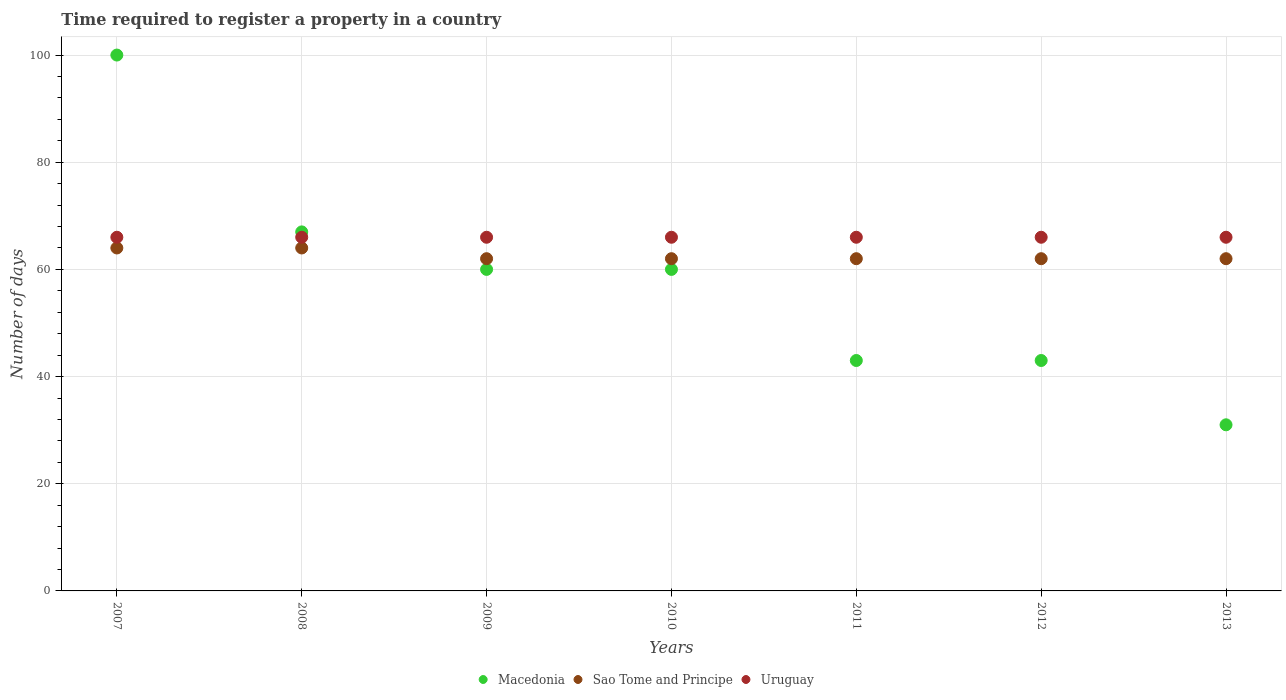How many different coloured dotlines are there?
Offer a terse response. 3. What is the number of days required to register a property in Sao Tome and Principe in 2009?
Make the answer very short. 62. Across all years, what is the maximum number of days required to register a property in Sao Tome and Principe?
Your answer should be very brief. 64. Across all years, what is the minimum number of days required to register a property in Sao Tome and Principe?
Offer a terse response. 62. What is the total number of days required to register a property in Macedonia in the graph?
Provide a succinct answer. 404. What is the difference between the number of days required to register a property in Macedonia in 2011 and the number of days required to register a property in Uruguay in 2007?
Give a very brief answer. -23. What is the average number of days required to register a property in Sao Tome and Principe per year?
Your response must be concise. 62.57. In the year 2007, what is the difference between the number of days required to register a property in Sao Tome and Principe and number of days required to register a property in Uruguay?
Your answer should be compact. -2. What is the ratio of the number of days required to register a property in Uruguay in 2007 to that in 2013?
Ensure brevity in your answer.  1. What is the difference between the highest and the lowest number of days required to register a property in Sao Tome and Principe?
Provide a short and direct response. 2. In how many years, is the number of days required to register a property in Uruguay greater than the average number of days required to register a property in Uruguay taken over all years?
Provide a succinct answer. 0. Does the number of days required to register a property in Uruguay monotonically increase over the years?
Keep it short and to the point. No. What is the difference between two consecutive major ticks on the Y-axis?
Ensure brevity in your answer.  20. Does the graph contain any zero values?
Give a very brief answer. No. Does the graph contain grids?
Give a very brief answer. Yes. How many legend labels are there?
Ensure brevity in your answer.  3. What is the title of the graph?
Provide a short and direct response. Time required to register a property in a country. What is the label or title of the X-axis?
Offer a very short reply. Years. What is the label or title of the Y-axis?
Keep it short and to the point. Number of days. What is the Number of days in Sao Tome and Principe in 2007?
Make the answer very short. 64. What is the Number of days in Uruguay in 2007?
Offer a very short reply. 66. What is the Number of days of Macedonia in 2008?
Offer a very short reply. 67. What is the Number of days in Sao Tome and Principe in 2008?
Offer a very short reply. 64. What is the Number of days in Uruguay in 2008?
Provide a succinct answer. 66. What is the Number of days of Macedonia in 2009?
Give a very brief answer. 60. What is the Number of days in Uruguay in 2009?
Ensure brevity in your answer.  66. What is the Number of days of Macedonia in 2010?
Offer a terse response. 60. What is the Number of days in Sao Tome and Principe in 2010?
Keep it short and to the point. 62. What is the Number of days in Sao Tome and Principe in 2011?
Your answer should be compact. 62. What is the Number of days in Sao Tome and Principe in 2012?
Give a very brief answer. 62. What is the Number of days of Uruguay in 2012?
Make the answer very short. 66. What is the Number of days in Macedonia in 2013?
Make the answer very short. 31. What is the Number of days in Sao Tome and Principe in 2013?
Ensure brevity in your answer.  62. Across all years, what is the maximum Number of days of Sao Tome and Principe?
Give a very brief answer. 64. Across all years, what is the minimum Number of days of Sao Tome and Principe?
Keep it short and to the point. 62. Across all years, what is the minimum Number of days in Uruguay?
Your answer should be very brief. 66. What is the total Number of days in Macedonia in the graph?
Ensure brevity in your answer.  404. What is the total Number of days in Sao Tome and Principe in the graph?
Give a very brief answer. 438. What is the total Number of days in Uruguay in the graph?
Your answer should be compact. 462. What is the difference between the Number of days of Macedonia in 2007 and that in 2008?
Give a very brief answer. 33. What is the difference between the Number of days in Sao Tome and Principe in 2007 and that in 2008?
Give a very brief answer. 0. What is the difference between the Number of days in Uruguay in 2007 and that in 2008?
Your response must be concise. 0. What is the difference between the Number of days of Macedonia in 2007 and that in 2009?
Your response must be concise. 40. What is the difference between the Number of days in Sao Tome and Principe in 2007 and that in 2009?
Your answer should be compact. 2. What is the difference between the Number of days of Macedonia in 2007 and that in 2010?
Your answer should be compact. 40. What is the difference between the Number of days in Sao Tome and Principe in 2007 and that in 2010?
Offer a terse response. 2. What is the difference between the Number of days of Macedonia in 2007 and that in 2011?
Your answer should be compact. 57. What is the difference between the Number of days in Sao Tome and Principe in 2007 and that in 2011?
Offer a very short reply. 2. What is the difference between the Number of days of Uruguay in 2007 and that in 2011?
Offer a very short reply. 0. What is the difference between the Number of days in Sao Tome and Principe in 2007 and that in 2012?
Provide a short and direct response. 2. What is the difference between the Number of days in Uruguay in 2007 and that in 2012?
Your response must be concise. 0. What is the difference between the Number of days in Sao Tome and Principe in 2007 and that in 2013?
Offer a terse response. 2. What is the difference between the Number of days in Uruguay in 2008 and that in 2009?
Provide a short and direct response. 0. What is the difference between the Number of days of Macedonia in 2008 and that in 2010?
Offer a terse response. 7. What is the difference between the Number of days of Uruguay in 2008 and that in 2011?
Make the answer very short. 0. What is the difference between the Number of days in Sao Tome and Principe in 2008 and that in 2012?
Give a very brief answer. 2. What is the difference between the Number of days in Macedonia in 2008 and that in 2013?
Your answer should be very brief. 36. What is the difference between the Number of days in Sao Tome and Principe in 2008 and that in 2013?
Keep it short and to the point. 2. What is the difference between the Number of days of Uruguay in 2008 and that in 2013?
Give a very brief answer. 0. What is the difference between the Number of days of Sao Tome and Principe in 2009 and that in 2010?
Provide a short and direct response. 0. What is the difference between the Number of days in Uruguay in 2009 and that in 2010?
Keep it short and to the point. 0. What is the difference between the Number of days of Macedonia in 2009 and that in 2011?
Keep it short and to the point. 17. What is the difference between the Number of days in Sao Tome and Principe in 2009 and that in 2011?
Give a very brief answer. 0. What is the difference between the Number of days of Uruguay in 2009 and that in 2011?
Give a very brief answer. 0. What is the difference between the Number of days in Sao Tome and Principe in 2009 and that in 2012?
Ensure brevity in your answer.  0. What is the difference between the Number of days of Macedonia in 2009 and that in 2013?
Provide a short and direct response. 29. What is the difference between the Number of days of Uruguay in 2010 and that in 2011?
Your answer should be very brief. 0. What is the difference between the Number of days of Macedonia in 2010 and that in 2012?
Offer a terse response. 17. What is the difference between the Number of days of Uruguay in 2010 and that in 2012?
Keep it short and to the point. 0. What is the difference between the Number of days of Sao Tome and Principe in 2010 and that in 2013?
Ensure brevity in your answer.  0. What is the difference between the Number of days of Uruguay in 2010 and that in 2013?
Your response must be concise. 0. What is the difference between the Number of days in Macedonia in 2011 and that in 2012?
Make the answer very short. 0. What is the difference between the Number of days of Uruguay in 2011 and that in 2012?
Make the answer very short. 0. What is the difference between the Number of days of Macedonia in 2011 and that in 2013?
Provide a short and direct response. 12. What is the difference between the Number of days in Sao Tome and Principe in 2011 and that in 2013?
Offer a terse response. 0. What is the difference between the Number of days in Macedonia in 2012 and that in 2013?
Make the answer very short. 12. What is the difference between the Number of days in Sao Tome and Principe in 2012 and that in 2013?
Your answer should be compact. 0. What is the difference between the Number of days of Uruguay in 2012 and that in 2013?
Ensure brevity in your answer.  0. What is the difference between the Number of days of Sao Tome and Principe in 2007 and the Number of days of Uruguay in 2008?
Keep it short and to the point. -2. What is the difference between the Number of days in Sao Tome and Principe in 2007 and the Number of days in Uruguay in 2009?
Offer a very short reply. -2. What is the difference between the Number of days of Macedonia in 2007 and the Number of days of Uruguay in 2010?
Your answer should be very brief. 34. What is the difference between the Number of days of Macedonia in 2007 and the Number of days of Sao Tome and Principe in 2011?
Offer a very short reply. 38. What is the difference between the Number of days of Macedonia in 2007 and the Number of days of Sao Tome and Principe in 2012?
Ensure brevity in your answer.  38. What is the difference between the Number of days in Macedonia in 2007 and the Number of days in Uruguay in 2012?
Give a very brief answer. 34. What is the difference between the Number of days in Sao Tome and Principe in 2007 and the Number of days in Uruguay in 2012?
Offer a terse response. -2. What is the difference between the Number of days of Macedonia in 2007 and the Number of days of Uruguay in 2013?
Make the answer very short. 34. What is the difference between the Number of days of Sao Tome and Principe in 2007 and the Number of days of Uruguay in 2013?
Give a very brief answer. -2. What is the difference between the Number of days of Macedonia in 2008 and the Number of days of Uruguay in 2009?
Your response must be concise. 1. What is the difference between the Number of days in Sao Tome and Principe in 2008 and the Number of days in Uruguay in 2009?
Provide a short and direct response. -2. What is the difference between the Number of days of Macedonia in 2008 and the Number of days of Uruguay in 2010?
Give a very brief answer. 1. What is the difference between the Number of days of Sao Tome and Principe in 2008 and the Number of days of Uruguay in 2010?
Your answer should be compact. -2. What is the difference between the Number of days in Macedonia in 2008 and the Number of days in Uruguay in 2011?
Make the answer very short. 1. What is the difference between the Number of days of Sao Tome and Principe in 2008 and the Number of days of Uruguay in 2011?
Keep it short and to the point. -2. What is the difference between the Number of days in Macedonia in 2008 and the Number of days in Sao Tome and Principe in 2013?
Ensure brevity in your answer.  5. What is the difference between the Number of days of Macedonia in 2008 and the Number of days of Uruguay in 2013?
Ensure brevity in your answer.  1. What is the difference between the Number of days in Macedonia in 2009 and the Number of days in Sao Tome and Principe in 2010?
Give a very brief answer. -2. What is the difference between the Number of days in Macedonia in 2009 and the Number of days in Sao Tome and Principe in 2011?
Make the answer very short. -2. What is the difference between the Number of days in Sao Tome and Principe in 2009 and the Number of days in Uruguay in 2011?
Make the answer very short. -4. What is the difference between the Number of days of Sao Tome and Principe in 2009 and the Number of days of Uruguay in 2012?
Provide a succinct answer. -4. What is the difference between the Number of days of Macedonia in 2009 and the Number of days of Sao Tome and Principe in 2013?
Make the answer very short. -2. What is the difference between the Number of days in Sao Tome and Principe in 2009 and the Number of days in Uruguay in 2013?
Offer a terse response. -4. What is the difference between the Number of days in Macedonia in 2010 and the Number of days in Sao Tome and Principe in 2011?
Give a very brief answer. -2. What is the difference between the Number of days in Macedonia in 2010 and the Number of days in Uruguay in 2012?
Make the answer very short. -6. What is the difference between the Number of days of Sao Tome and Principe in 2010 and the Number of days of Uruguay in 2012?
Ensure brevity in your answer.  -4. What is the difference between the Number of days in Macedonia in 2010 and the Number of days in Uruguay in 2013?
Provide a succinct answer. -6. What is the difference between the Number of days in Macedonia in 2011 and the Number of days in Uruguay in 2012?
Offer a terse response. -23. What is the difference between the Number of days of Macedonia in 2011 and the Number of days of Sao Tome and Principe in 2013?
Your answer should be compact. -19. What is the difference between the Number of days of Sao Tome and Principe in 2011 and the Number of days of Uruguay in 2013?
Offer a terse response. -4. What is the average Number of days in Macedonia per year?
Provide a short and direct response. 57.71. What is the average Number of days of Sao Tome and Principe per year?
Make the answer very short. 62.57. In the year 2007, what is the difference between the Number of days of Macedonia and Number of days of Uruguay?
Ensure brevity in your answer.  34. In the year 2007, what is the difference between the Number of days of Sao Tome and Principe and Number of days of Uruguay?
Ensure brevity in your answer.  -2. In the year 2008, what is the difference between the Number of days in Sao Tome and Principe and Number of days in Uruguay?
Provide a succinct answer. -2. In the year 2009, what is the difference between the Number of days of Macedonia and Number of days of Sao Tome and Principe?
Your answer should be compact. -2. In the year 2009, what is the difference between the Number of days in Macedonia and Number of days in Uruguay?
Give a very brief answer. -6. In the year 2010, what is the difference between the Number of days in Macedonia and Number of days in Sao Tome and Principe?
Offer a very short reply. -2. In the year 2010, what is the difference between the Number of days in Macedonia and Number of days in Uruguay?
Give a very brief answer. -6. In the year 2011, what is the difference between the Number of days of Macedonia and Number of days of Sao Tome and Principe?
Keep it short and to the point. -19. In the year 2011, what is the difference between the Number of days of Macedonia and Number of days of Uruguay?
Your response must be concise. -23. In the year 2011, what is the difference between the Number of days of Sao Tome and Principe and Number of days of Uruguay?
Offer a very short reply. -4. In the year 2012, what is the difference between the Number of days of Macedonia and Number of days of Sao Tome and Principe?
Keep it short and to the point. -19. In the year 2012, what is the difference between the Number of days in Macedonia and Number of days in Uruguay?
Offer a very short reply. -23. In the year 2013, what is the difference between the Number of days in Macedonia and Number of days in Sao Tome and Principe?
Your response must be concise. -31. In the year 2013, what is the difference between the Number of days of Macedonia and Number of days of Uruguay?
Your answer should be very brief. -35. In the year 2013, what is the difference between the Number of days in Sao Tome and Principe and Number of days in Uruguay?
Offer a terse response. -4. What is the ratio of the Number of days of Macedonia in 2007 to that in 2008?
Give a very brief answer. 1.49. What is the ratio of the Number of days in Uruguay in 2007 to that in 2008?
Your response must be concise. 1. What is the ratio of the Number of days of Sao Tome and Principe in 2007 to that in 2009?
Offer a very short reply. 1.03. What is the ratio of the Number of days of Uruguay in 2007 to that in 2009?
Make the answer very short. 1. What is the ratio of the Number of days in Sao Tome and Principe in 2007 to that in 2010?
Your answer should be very brief. 1.03. What is the ratio of the Number of days in Uruguay in 2007 to that in 2010?
Offer a terse response. 1. What is the ratio of the Number of days of Macedonia in 2007 to that in 2011?
Provide a short and direct response. 2.33. What is the ratio of the Number of days in Sao Tome and Principe in 2007 to that in 2011?
Give a very brief answer. 1.03. What is the ratio of the Number of days of Uruguay in 2007 to that in 2011?
Your response must be concise. 1. What is the ratio of the Number of days in Macedonia in 2007 to that in 2012?
Ensure brevity in your answer.  2.33. What is the ratio of the Number of days in Sao Tome and Principe in 2007 to that in 2012?
Your answer should be compact. 1.03. What is the ratio of the Number of days of Macedonia in 2007 to that in 2013?
Offer a terse response. 3.23. What is the ratio of the Number of days in Sao Tome and Principe in 2007 to that in 2013?
Give a very brief answer. 1.03. What is the ratio of the Number of days of Macedonia in 2008 to that in 2009?
Provide a succinct answer. 1.12. What is the ratio of the Number of days of Sao Tome and Principe in 2008 to that in 2009?
Your answer should be compact. 1.03. What is the ratio of the Number of days of Macedonia in 2008 to that in 2010?
Your response must be concise. 1.12. What is the ratio of the Number of days in Sao Tome and Principe in 2008 to that in 2010?
Your response must be concise. 1.03. What is the ratio of the Number of days of Uruguay in 2008 to that in 2010?
Your answer should be very brief. 1. What is the ratio of the Number of days of Macedonia in 2008 to that in 2011?
Provide a short and direct response. 1.56. What is the ratio of the Number of days of Sao Tome and Principe in 2008 to that in 2011?
Keep it short and to the point. 1.03. What is the ratio of the Number of days in Uruguay in 2008 to that in 2011?
Your response must be concise. 1. What is the ratio of the Number of days in Macedonia in 2008 to that in 2012?
Keep it short and to the point. 1.56. What is the ratio of the Number of days in Sao Tome and Principe in 2008 to that in 2012?
Offer a very short reply. 1.03. What is the ratio of the Number of days in Uruguay in 2008 to that in 2012?
Offer a terse response. 1. What is the ratio of the Number of days in Macedonia in 2008 to that in 2013?
Ensure brevity in your answer.  2.16. What is the ratio of the Number of days of Sao Tome and Principe in 2008 to that in 2013?
Your answer should be compact. 1.03. What is the ratio of the Number of days in Uruguay in 2008 to that in 2013?
Your response must be concise. 1. What is the ratio of the Number of days of Macedonia in 2009 to that in 2010?
Your answer should be very brief. 1. What is the ratio of the Number of days of Sao Tome and Principe in 2009 to that in 2010?
Offer a very short reply. 1. What is the ratio of the Number of days in Uruguay in 2009 to that in 2010?
Your answer should be compact. 1. What is the ratio of the Number of days in Macedonia in 2009 to that in 2011?
Offer a terse response. 1.4. What is the ratio of the Number of days in Sao Tome and Principe in 2009 to that in 2011?
Provide a succinct answer. 1. What is the ratio of the Number of days in Macedonia in 2009 to that in 2012?
Provide a short and direct response. 1.4. What is the ratio of the Number of days in Uruguay in 2009 to that in 2012?
Offer a terse response. 1. What is the ratio of the Number of days in Macedonia in 2009 to that in 2013?
Give a very brief answer. 1.94. What is the ratio of the Number of days of Sao Tome and Principe in 2009 to that in 2013?
Provide a short and direct response. 1. What is the ratio of the Number of days in Macedonia in 2010 to that in 2011?
Make the answer very short. 1.4. What is the ratio of the Number of days in Macedonia in 2010 to that in 2012?
Provide a short and direct response. 1.4. What is the ratio of the Number of days of Sao Tome and Principe in 2010 to that in 2012?
Offer a very short reply. 1. What is the ratio of the Number of days of Macedonia in 2010 to that in 2013?
Offer a very short reply. 1.94. What is the ratio of the Number of days of Sao Tome and Principe in 2010 to that in 2013?
Make the answer very short. 1. What is the ratio of the Number of days of Macedonia in 2011 to that in 2012?
Your answer should be compact. 1. What is the ratio of the Number of days of Sao Tome and Principe in 2011 to that in 2012?
Keep it short and to the point. 1. What is the ratio of the Number of days of Uruguay in 2011 to that in 2012?
Make the answer very short. 1. What is the ratio of the Number of days in Macedonia in 2011 to that in 2013?
Give a very brief answer. 1.39. What is the ratio of the Number of days of Macedonia in 2012 to that in 2013?
Make the answer very short. 1.39. What is the ratio of the Number of days of Sao Tome and Principe in 2012 to that in 2013?
Make the answer very short. 1. What is the difference between the highest and the second highest Number of days of Macedonia?
Provide a succinct answer. 33. What is the difference between the highest and the second highest Number of days in Sao Tome and Principe?
Make the answer very short. 0. What is the difference between the highest and the second highest Number of days in Uruguay?
Provide a succinct answer. 0. 